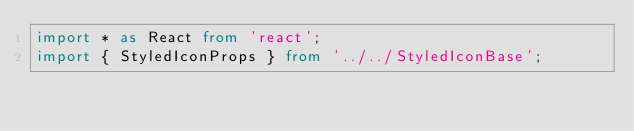Convert code to text. <code><loc_0><loc_0><loc_500><loc_500><_TypeScript_>import * as React from 'react';
import { StyledIconProps } from '../../StyledIconBase';</code> 